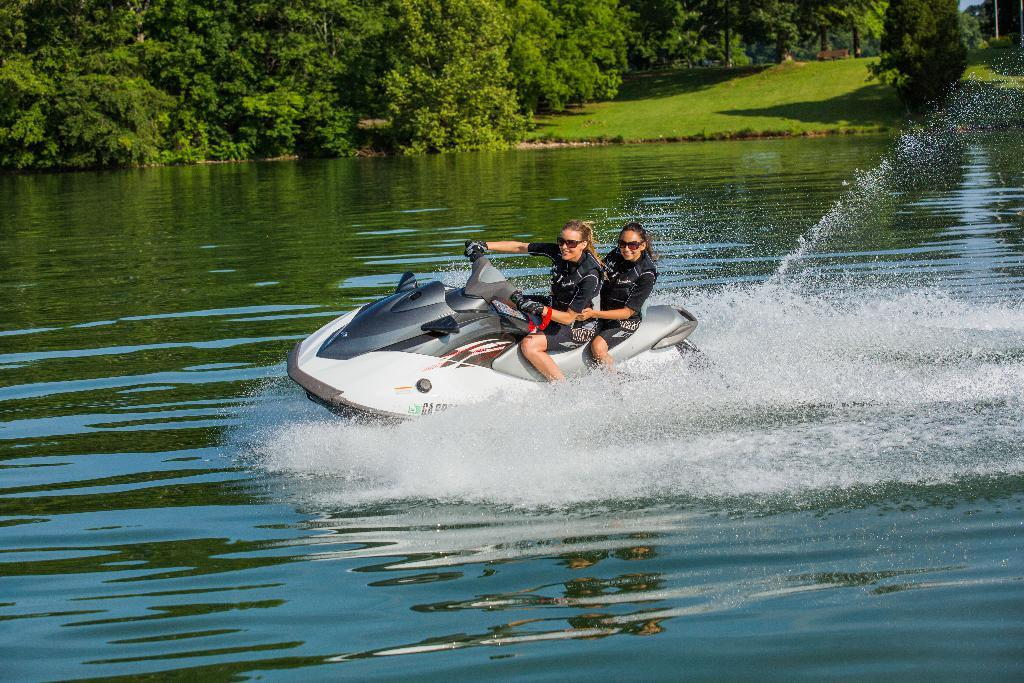How many people are in the image? There are two women in the image. What activity are the women engaged in? The women are doing jet ski. What can be seen in the background of the image? There are trees in the background of the image. What is the terrain like in the image? The land is full of grass. What time is displayed on the clock in the image? There is no clock present in the image. What type of house can be seen in the background of the image? There is no house visible in the image; only trees are present in the background. 